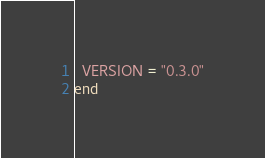<code> <loc_0><loc_0><loc_500><loc_500><_Ruby_>  VERSION = "0.3.0"
end
</code> 